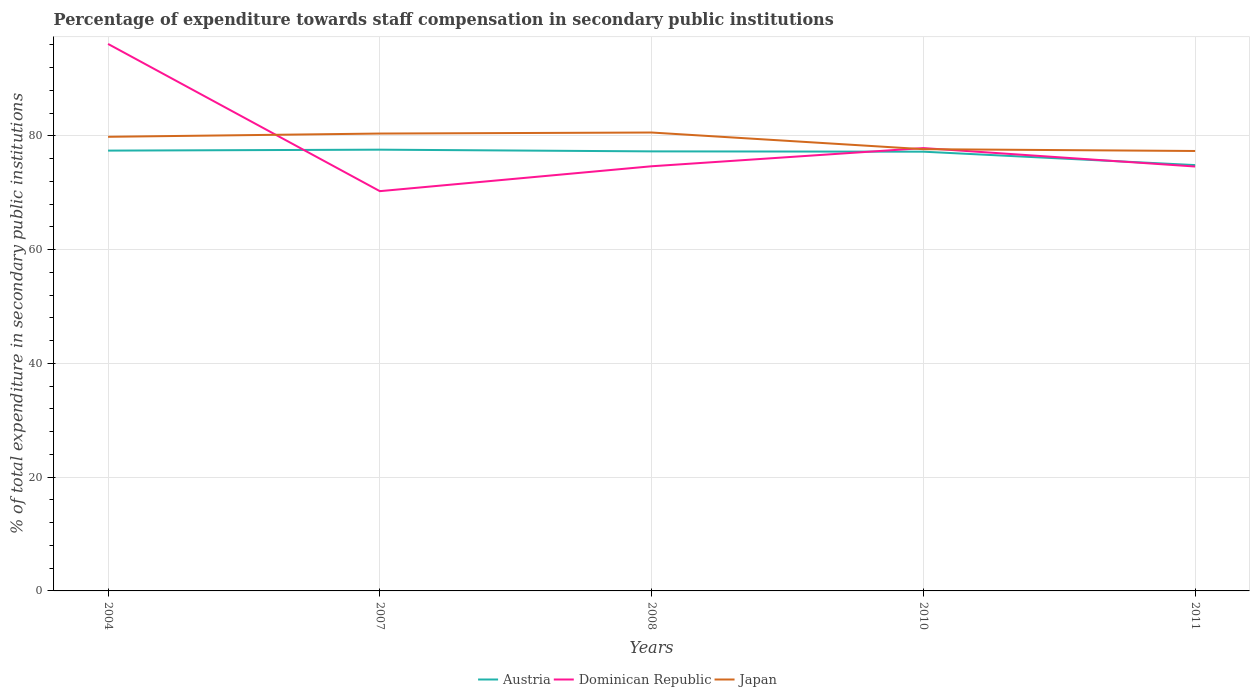Across all years, what is the maximum percentage of expenditure towards staff compensation in Japan?
Your answer should be very brief. 77.36. In which year was the percentage of expenditure towards staff compensation in Dominican Republic maximum?
Provide a short and direct response. 2007. What is the total percentage of expenditure towards staff compensation in Dominican Republic in the graph?
Ensure brevity in your answer.  18.31. What is the difference between the highest and the second highest percentage of expenditure towards staff compensation in Japan?
Make the answer very short. 3.25. What is the difference between the highest and the lowest percentage of expenditure towards staff compensation in Dominican Republic?
Offer a very short reply. 1. Does the graph contain any zero values?
Your answer should be very brief. No. Does the graph contain grids?
Offer a terse response. Yes. How are the legend labels stacked?
Provide a succinct answer. Horizontal. What is the title of the graph?
Ensure brevity in your answer.  Percentage of expenditure towards staff compensation in secondary public institutions. What is the label or title of the X-axis?
Your response must be concise. Years. What is the label or title of the Y-axis?
Offer a terse response. % of total expenditure in secondary public institutions. What is the % of total expenditure in secondary public institutions in Austria in 2004?
Your answer should be compact. 77.43. What is the % of total expenditure in secondary public institutions of Dominican Republic in 2004?
Keep it short and to the point. 96.18. What is the % of total expenditure in secondary public institutions of Japan in 2004?
Provide a succinct answer. 79.85. What is the % of total expenditure in secondary public institutions in Austria in 2007?
Your response must be concise. 77.59. What is the % of total expenditure in secondary public institutions in Dominican Republic in 2007?
Provide a succinct answer. 70.3. What is the % of total expenditure in secondary public institutions of Japan in 2007?
Ensure brevity in your answer.  80.43. What is the % of total expenditure in secondary public institutions of Austria in 2008?
Your answer should be compact. 77.29. What is the % of total expenditure in secondary public institutions in Dominican Republic in 2008?
Ensure brevity in your answer.  74.67. What is the % of total expenditure in secondary public institutions of Japan in 2008?
Provide a short and direct response. 80.61. What is the % of total expenditure in secondary public institutions of Austria in 2010?
Provide a short and direct response. 77.24. What is the % of total expenditure in secondary public institutions in Dominican Republic in 2010?
Offer a terse response. 77.87. What is the % of total expenditure in secondary public institutions in Japan in 2010?
Provide a short and direct response. 77.68. What is the % of total expenditure in secondary public institutions in Austria in 2011?
Ensure brevity in your answer.  74.88. What is the % of total expenditure in secondary public institutions in Dominican Republic in 2011?
Your answer should be very brief. 74.63. What is the % of total expenditure in secondary public institutions in Japan in 2011?
Provide a succinct answer. 77.36. Across all years, what is the maximum % of total expenditure in secondary public institutions in Austria?
Provide a succinct answer. 77.59. Across all years, what is the maximum % of total expenditure in secondary public institutions of Dominican Republic?
Give a very brief answer. 96.18. Across all years, what is the maximum % of total expenditure in secondary public institutions in Japan?
Provide a short and direct response. 80.61. Across all years, what is the minimum % of total expenditure in secondary public institutions of Austria?
Keep it short and to the point. 74.88. Across all years, what is the minimum % of total expenditure in secondary public institutions of Dominican Republic?
Your answer should be very brief. 70.3. Across all years, what is the minimum % of total expenditure in secondary public institutions of Japan?
Offer a terse response. 77.36. What is the total % of total expenditure in secondary public institutions of Austria in the graph?
Your answer should be very brief. 384.42. What is the total % of total expenditure in secondary public institutions of Dominican Republic in the graph?
Ensure brevity in your answer.  393.65. What is the total % of total expenditure in secondary public institutions of Japan in the graph?
Provide a short and direct response. 395.92. What is the difference between the % of total expenditure in secondary public institutions of Austria in 2004 and that in 2007?
Give a very brief answer. -0.17. What is the difference between the % of total expenditure in secondary public institutions in Dominican Republic in 2004 and that in 2007?
Ensure brevity in your answer.  25.89. What is the difference between the % of total expenditure in secondary public institutions in Japan in 2004 and that in 2007?
Ensure brevity in your answer.  -0.57. What is the difference between the % of total expenditure in secondary public institutions in Austria in 2004 and that in 2008?
Offer a terse response. 0.13. What is the difference between the % of total expenditure in secondary public institutions of Dominican Republic in 2004 and that in 2008?
Offer a terse response. 21.51. What is the difference between the % of total expenditure in secondary public institutions in Japan in 2004 and that in 2008?
Keep it short and to the point. -0.75. What is the difference between the % of total expenditure in secondary public institutions in Austria in 2004 and that in 2010?
Your response must be concise. 0.19. What is the difference between the % of total expenditure in secondary public institutions in Dominican Republic in 2004 and that in 2010?
Keep it short and to the point. 18.31. What is the difference between the % of total expenditure in secondary public institutions of Japan in 2004 and that in 2010?
Offer a very short reply. 2.18. What is the difference between the % of total expenditure in secondary public institutions of Austria in 2004 and that in 2011?
Your answer should be very brief. 2.55. What is the difference between the % of total expenditure in secondary public institutions of Dominican Republic in 2004 and that in 2011?
Your answer should be compact. 21.56. What is the difference between the % of total expenditure in secondary public institutions in Japan in 2004 and that in 2011?
Give a very brief answer. 2.49. What is the difference between the % of total expenditure in secondary public institutions in Austria in 2007 and that in 2008?
Provide a succinct answer. 0.3. What is the difference between the % of total expenditure in secondary public institutions of Dominican Republic in 2007 and that in 2008?
Keep it short and to the point. -4.38. What is the difference between the % of total expenditure in secondary public institutions in Japan in 2007 and that in 2008?
Provide a short and direct response. -0.18. What is the difference between the % of total expenditure in secondary public institutions in Austria in 2007 and that in 2010?
Ensure brevity in your answer.  0.35. What is the difference between the % of total expenditure in secondary public institutions of Dominican Republic in 2007 and that in 2010?
Your answer should be very brief. -7.58. What is the difference between the % of total expenditure in secondary public institutions of Japan in 2007 and that in 2010?
Your response must be concise. 2.75. What is the difference between the % of total expenditure in secondary public institutions of Austria in 2007 and that in 2011?
Make the answer very short. 2.71. What is the difference between the % of total expenditure in secondary public institutions in Dominican Republic in 2007 and that in 2011?
Give a very brief answer. -4.33. What is the difference between the % of total expenditure in secondary public institutions of Japan in 2007 and that in 2011?
Give a very brief answer. 3.07. What is the difference between the % of total expenditure in secondary public institutions of Austria in 2008 and that in 2010?
Offer a terse response. 0.06. What is the difference between the % of total expenditure in secondary public institutions in Dominican Republic in 2008 and that in 2010?
Offer a terse response. -3.2. What is the difference between the % of total expenditure in secondary public institutions of Japan in 2008 and that in 2010?
Give a very brief answer. 2.93. What is the difference between the % of total expenditure in secondary public institutions in Austria in 2008 and that in 2011?
Give a very brief answer. 2.41. What is the difference between the % of total expenditure in secondary public institutions of Dominican Republic in 2008 and that in 2011?
Ensure brevity in your answer.  0.05. What is the difference between the % of total expenditure in secondary public institutions in Japan in 2008 and that in 2011?
Give a very brief answer. 3.25. What is the difference between the % of total expenditure in secondary public institutions in Austria in 2010 and that in 2011?
Your response must be concise. 2.36. What is the difference between the % of total expenditure in secondary public institutions in Dominican Republic in 2010 and that in 2011?
Ensure brevity in your answer.  3.24. What is the difference between the % of total expenditure in secondary public institutions of Japan in 2010 and that in 2011?
Provide a succinct answer. 0.32. What is the difference between the % of total expenditure in secondary public institutions in Austria in 2004 and the % of total expenditure in secondary public institutions in Dominican Republic in 2007?
Keep it short and to the point. 7.13. What is the difference between the % of total expenditure in secondary public institutions in Austria in 2004 and the % of total expenditure in secondary public institutions in Japan in 2007?
Your answer should be compact. -3. What is the difference between the % of total expenditure in secondary public institutions in Dominican Republic in 2004 and the % of total expenditure in secondary public institutions in Japan in 2007?
Ensure brevity in your answer.  15.76. What is the difference between the % of total expenditure in secondary public institutions in Austria in 2004 and the % of total expenditure in secondary public institutions in Dominican Republic in 2008?
Your answer should be compact. 2.75. What is the difference between the % of total expenditure in secondary public institutions of Austria in 2004 and the % of total expenditure in secondary public institutions of Japan in 2008?
Provide a succinct answer. -3.18. What is the difference between the % of total expenditure in secondary public institutions in Dominican Republic in 2004 and the % of total expenditure in secondary public institutions in Japan in 2008?
Keep it short and to the point. 15.58. What is the difference between the % of total expenditure in secondary public institutions in Austria in 2004 and the % of total expenditure in secondary public institutions in Dominican Republic in 2010?
Your answer should be compact. -0.45. What is the difference between the % of total expenditure in secondary public institutions of Austria in 2004 and the % of total expenditure in secondary public institutions of Japan in 2010?
Provide a succinct answer. -0.25. What is the difference between the % of total expenditure in secondary public institutions of Dominican Republic in 2004 and the % of total expenditure in secondary public institutions of Japan in 2010?
Provide a succinct answer. 18.51. What is the difference between the % of total expenditure in secondary public institutions of Austria in 2004 and the % of total expenditure in secondary public institutions of Dominican Republic in 2011?
Your answer should be compact. 2.8. What is the difference between the % of total expenditure in secondary public institutions in Austria in 2004 and the % of total expenditure in secondary public institutions in Japan in 2011?
Provide a short and direct response. 0.07. What is the difference between the % of total expenditure in secondary public institutions in Dominican Republic in 2004 and the % of total expenditure in secondary public institutions in Japan in 2011?
Make the answer very short. 18.82. What is the difference between the % of total expenditure in secondary public institutions in Austria in 2007 and the % of total expenditure in secondary public institutions in Dominican Republic in 2008?
Keep it short and to the point. 2.92. What is the difference between the % of total expenditure in secondary public institutions of Austria in 2007 and the % of total expenditure in secondary public institutions of Japan in 2008?
Give a very brief answer. -3.02. What is the difference between the % of total expenditure in secondary public institutions in Dominican Republic in 2007 and the % of total expenditure in secondary public institutions in Japan in 2008?
Your answer should be compact. -10.31. What is the difference between the % of total expenditure in secondary public institutions of Austria in 2007 and the % of total expenditure in secondary public institutions of Dominican Republic in 2010?
Offer a terse response. -0.28. What is the difference between the % of total expenditure in secondary public institutions in Austria in 2007 and the % of total expenditure in secondary public institutions in Japan in 2010?
Make the answer very short. -0.08. What is the difference between the % of total expenditure in secondary public institutions in Dominican Republic in 2007 and the % of total expenditure in secondary public institutions in Japan in 2010?
Provide a succinct answer. -7.38. What is the difference between the % of total expenditure in secondary public institutions of Austria in 2007 and the % of total expenditure in secondary public institutions of Dominican Republic in 2011?
Keep it short and to the point. 2.96. What is the difference between the % of total expenditure in secondary public institutions of Austria in 2007 and the % of total expenditure in secondary public institutions of Japan in 2011?
Your answer should be very brief. 0.23. What is the difference between the % of total expenditure in secondary public institutions in Dominican Republic in 2007 and the % of total expenditure in secondary public institutions in Japan in 2011?
Offer a terse response. -7.06. What is the difference between the % of total expenditure in secondary public institutions of Austria in 2008 and the % of total expenditure in secondary public institutions of Dominican Republic in 2010?
Make the answer very short. -0.58. What is the difference between the % of total expenditure in secondary public institutions in Austria in 2008 and the % of total expenditure in secondary public institutions in Japan in 2010?
Keep it short and to the point. -0.38. What is the difference between the % of total expenditure in secondary public institutions in Dominican Republic in 2008 and the % of total expenditure in secondary public institutions in Japan in 2010?
Make the answer very short. -3. What is the difference between the % of total expenditure in secondary public institutions in Austria in 2008 and the % of total expenditure in secondary public institutions in Dominican Republic in 2011?
Provide a short and direct response. 2.66. What is the difference between the % of total expenditure in secondary public institutions in Austria in 2008 and the % of total expenditure in secondary public institutions in Japan in 2011?
Offer a very short reply. -0.07. What is the difference between the % of total expenditure in secondary public institutions of Dominican Republic in 2008 and the % of total expenditure in secondary public institutions of Japan in 2011?
Ensure brevity in your answer.  -2.69. What is the difference between the % of total expenditure in secondary public institutions in Austria in 2010 and the % of total expenditure in secondary public institutions in Dominican Republic in 2011?
Provide a short and direct response. 2.61. What is the difference between the % of total expenditure in secondary public institutions of Austria in 2010 and the % of total expenditure in secondary public institutions of Japan in 2011?
Ensure brevity in your answer.  -0.12. What is the difference between the % of total expenditure in secondary public institutions of Dominican Republic in 2010 and the % of total expenditure in secondary public institutions of Japan in 2011?
Keep it short and to the point. 0.51. What is the average % of total expenditure in secondary public institutions of Austria per year?
Your answer should be compact. 76.88. What is the average % of total expenditure in secondary public institutions in Dominican Republic per year?
Offer a terse response. 78.73. What is the average % of total expenditure in secondary public institutions of Japan per year?
Provide a succinct answer. 79.18. In the year 2004, what is the difference between the % of total expenditure in secondary public institutions in Austria and % of total expenditure in secondary public institutions in Dominican Republic?
Your response must be concise. -18.76. In the year 2004, what is the difference between the % of total expenditure in secondary public institutions of Austria and % of total expenditure in secondary public institutions of Japan?
Make the answer very short. -2.43. In the year 2004, what is the difference between the % of total expenditure in secondary public institutions of Dominican Republic and % of total expenditure in secondary public institutions of Japan?
Your answer should be very brief. 16.33. In the year 2007, what is the difference between the % of total expenditure in secondary public institutions in Austria and % of total expenditure in secondary public institutions in Dominican Republic?
Keep it short and to the point. 7.29. In the year 2007, what is the difference between the % of total expenditure in secondary public institutions in Austria and % of total expenditure in secondary public institutions in Japan?
Keep it short and to the point. -2.84. In the year 2007, what is the difference between the % of total expenditure in secondary public institutions of Dominican Republic and % of total expenditure in secondary public institutions of Japan?
Your answer should be very brief. -10.13. In the year 2008, what is the difference between the % of total expenditure in secondary public institutions of Austria and % of total expenditure in secondary public institutions of Dominican Republic?
Your answer should be compact. 2.62. In the year 2008, what is the difference between the % of total expenditure in secondary public institutions in Austria and % of total expenditure in secondary public institutions in Japan?
Offer a terse response. -3.32. In the year 2008, what is the difference between the % of total expenditure in secondary public institutions in Dominican Republic and % of total expenditure in secondary public institutions in Japan?
Your response must be concise. -5.93. In the year 2010, what is the difference between the % of total expenditure in secondary public institutions of Austria and % of total expenditure in secondary public institutions of Dominican Republic?
Offer a very short reply. -0.63. In the year 2010, what is the difference between the % of total expenditure in secondary public institutions in Austria and % of total expenditure in secondary public institutions in Japan?
Your answer should be compact. -0.44. In the year 2010, what is the difference between the % of total expenditure in secondary public institutions of Dominican Republic and % of total expenditure in secondary public institutions of Japan?
Keep it short and to the point. 0.2. In the year 2011, what is the difference between the % of total expenditure in secondary public institutions of Austria and % of total expenditure in secondary public institutions of Dominican Republic?
Your answer should be compact. 0.25. In the year 2011, what is the difference between the % of total expenditure in secondary public institutions in Austria and % of total expenditure in secondary public institutions in Japan?
Keep it short and to the point. -2.48. In the year 2011, what is the difference between the % of total expenditure in secondary public institutions of Dominican Republic and % of total expenditure in secondary public institutions of Japan?
Your answer should be very brief. -2.73. What is the ratio of the % of total expenditure in secondary public institutions of Austria in 2004 to that in 2007?
Provide a succinct answer. 1. What is the ratio of the % of total expenditure in secondary public institutions of Dominican Republic in 2004 to that in 2007?
Give a very brief answer. 1.37. What is the ratio of the % of total expenditure in secondary public institutions in Dominican Republic in 2004 to that in 2008?
Your response must be concise. 1.29. What is the ratio of the % of total expenditure in secondary public institutions of Austria in 2004 to that in 2010?
Your answer should be very brief. 1. What is the ratio of the % of total expenditure in secondary public institutions of Dominican Republic in 2004 to that in 2010?
Your answer should be very brief. 1.24. What is the ratio of the % of total expenditure in secondary public institutions in Japan in 2004 to that in 2010?
Provide a succinct answer. 1.03. What is the ratio of the % of total expenditure in secondary public institutions of Austria in 2004 to that in 2011?
Provide a short and direct response. 1.03. What is the ratio of the % of total expenditure in secondary public institutions of Dominican Republic in 2004 to that in 2011?
Make the answer very short. 1.29. What is the ratio of the % of total expenditure in secondary public institutions of Japan in 2004 to that in 2011?
Your answer should be compact. 1.03. What is the ratio of the % of total expenditure in secondary public institutions in Austria in 2007 to that in 2008?
Ensure brevity in your answer.  1. What is the ratio of the % of total expenditure in secondary public institutions of Dominican Republic in 2007 to that in 2008?
Make the answer very short. 0.94. What is the ratio of the % of total expenditure in secondary public institutions in Japan in 2007 to that in 2008?
Provide a succinct answer. 1. What is the ratio of the % of total expenditure in secondary public institutions in Dominican Republic in 2007 to that in 2010?
Your answer should be compact. 0.9. What is the ratio of the % of total expenditure in secondary public institutions in Japan in 2007 to that in 2010?
Ensure brevity in your answer.  1.04. What is the ratio of the % of total expenditure in secondary public institutions in Austria in 2007 to that in 2011?
Your answer should be compact. 1.04. What is the ratio of the % of total expenditure in secondary public institutions of Dominican Republic in 2007 to that in 2011?
Keep it short and to the point. 0.94. What is the ratio of the % of total expenditure in secondary public institutions of Japan in 2007 to that in 2011?
Your answer should be very brief. 1.04. What is the ratio of the % of total expenditure in secondary public institutions of Austria in 2008 to that in 2010?
Keep it short and to the point. 1. What is the ratio of the % of total expenditure in secondary public institutions of Dominican Republic in 2008 to that in 2010?
Ensure brevity in your answer.  0.96. What is the ratio of the % of total expenditure in secondary public institutions of Japan in 2008 to that in 2010?
Provide a short and direct response. 1.04. What is the ratio of the % of total expenditure in secondary public institutions of Austria in 2008 to that in 2011?
Offer a terse response. 1.03. What is the ratio of the % of total expenditure in secondary public institutions of Dominican Republic in 2008 to that in 2011?
Give a very brief answer. 1. What is the ratio of the % of total expenditure in secondary public institutions in Japan in 2008 to that in 2011?
Your answer should be compact. 1.04. What is the ratio of the % of total expenditure in secondary public institutions in Austria in 2010 to that in 2011?
Provide a short and direct response. 1.03. What is the ratio of the % of total expenditure in secondary public institutions in Dominican Republic in 2010 to that in 2011?
Ensure brevity in your answer.  1.04. What is the difference between the highest and the second highest % of total expenditure in secondary public institutions in Austria?
Provide a succinct answer. 0.17. What is the difference between the highest and the second highest % of total expenditure in secondary public institutions in Dominican Republic?
Your answer should be compact. 18.31. What is the difference between the highest and the second highest % of total expenditure in secondary public institutions of Japan?
Your response must be concise. 0.18. What is the difference between the highest and the lowest % of total expenditure in secondary public institutions in Austria?
Ensure brevity in your answer.  2.71. What is the difference between the highest and the lowest % of total expenditure in secondary public institutions in Dominican Republic?
Your response must be concise. 25.89. What is the difference between the highest and the lowest % of total expenditure in secondary public institutions in Japan?
Offer a very short reply. 3.25. 